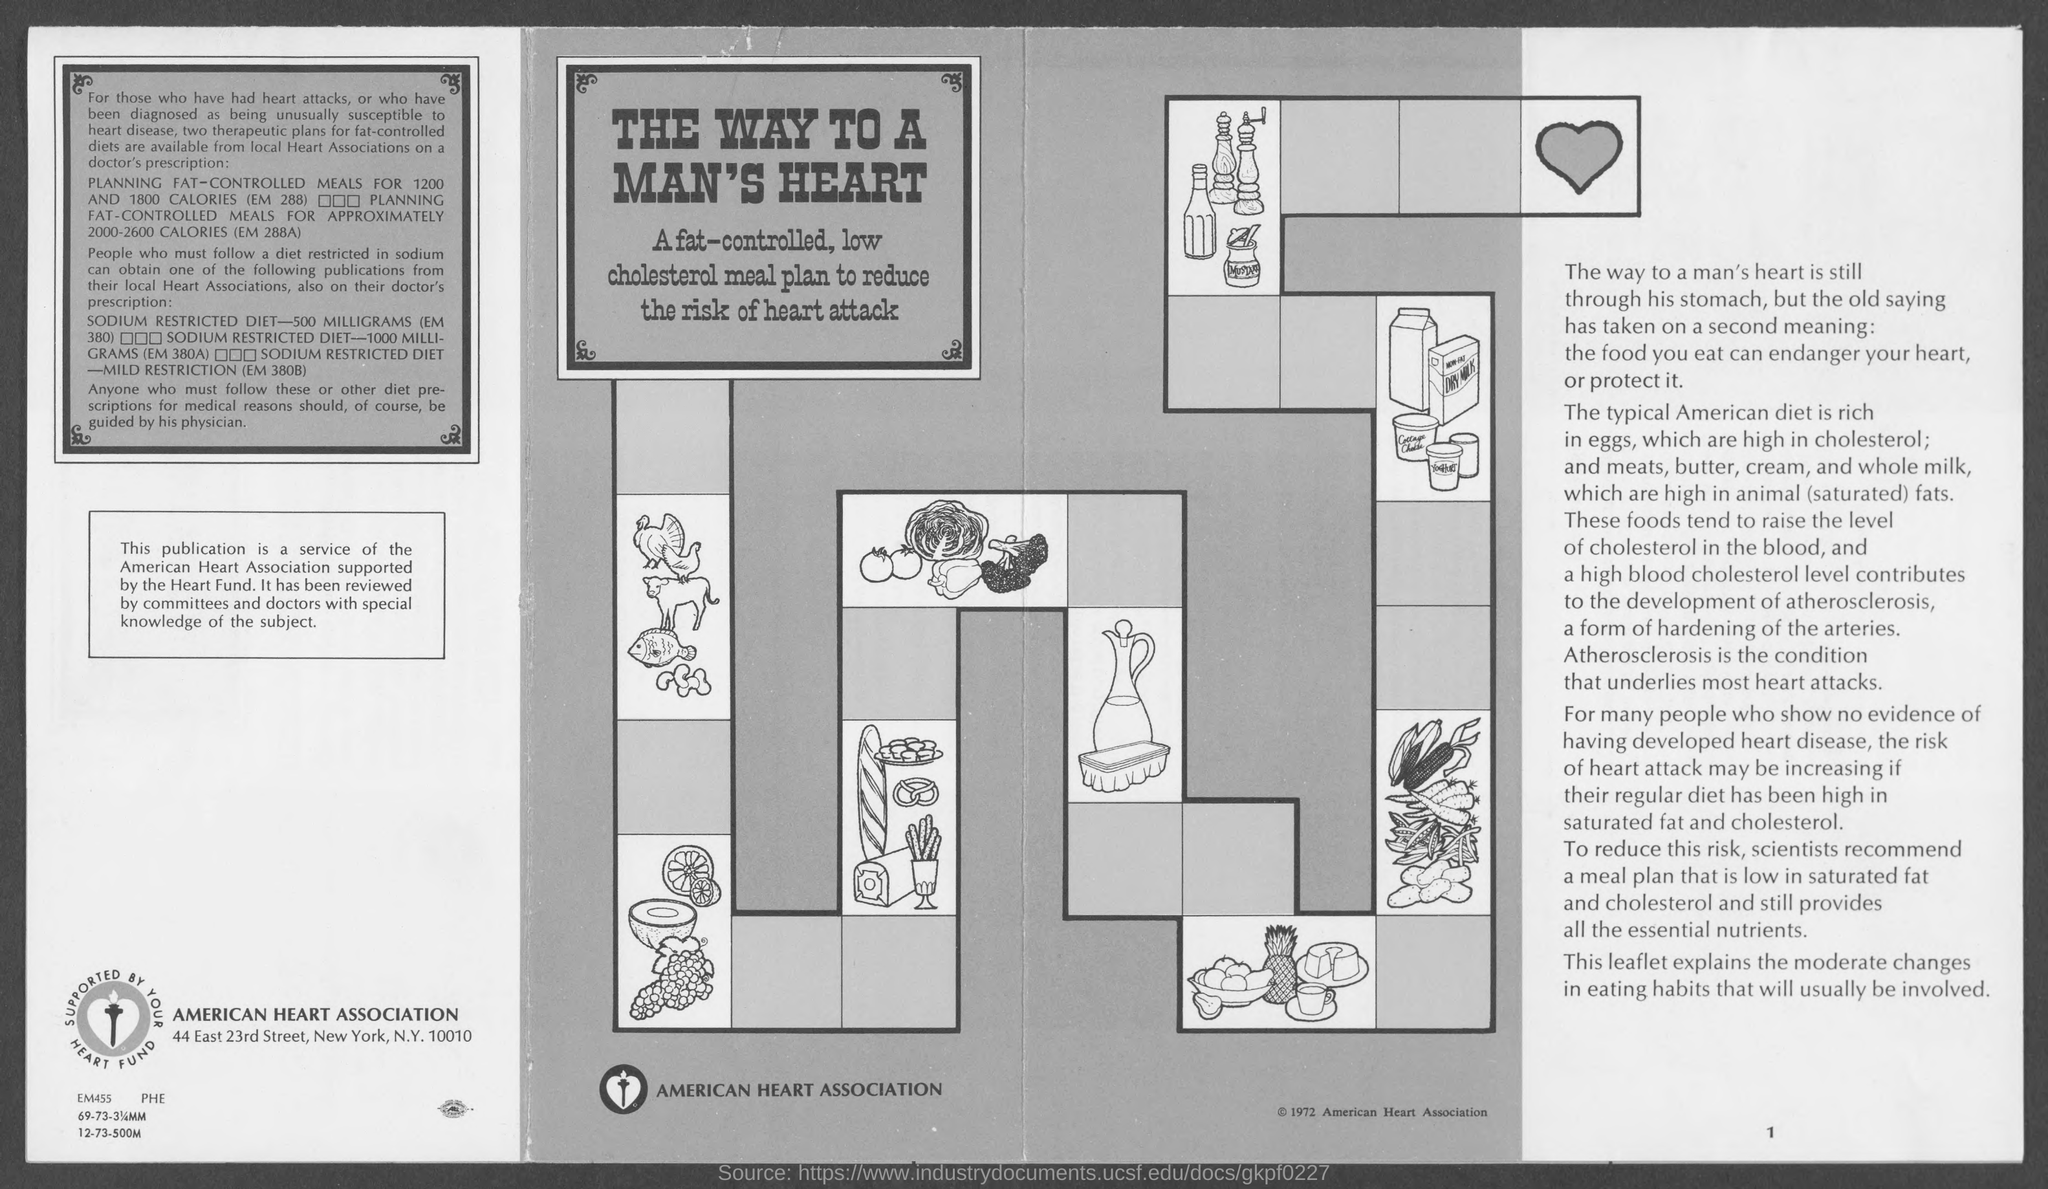Highlight a few significant elements in this photo. The name of the heart association is the American Heart Association. The American Heart Association is located at 44 East 23rd Street. 